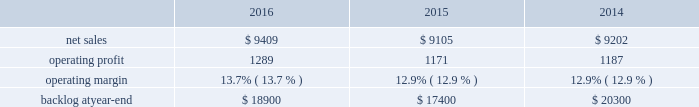Segment includes awe and our share of earnings for our investment in ula , which provides expendable launch services to the u.s .
Government .
Space systems 2019 operating results included the following ( in millions ) : .
2016 compared to 2015 space systems 2019 net sales in 2016 increased $ 304 million , or 3% ( 3 % ) , compared to 2015 .
The increase was attributable to net sales of approximately $ 410 million from awe following the consolidation of this business in the third quarter of 2016 ; and approximately $ 150 million for commercial space transportation programs due to increased launch-related activities ; and approximately $ 70 million of higher net sales for various programs ( primarily fleet ballistic missiles ) due to increased volume .
These increases were partially offset by a decrease in net sales of approximately $ 340 million for government satellite programs due to decreased volume ( primarily sbirs and muos ) and the wind-down or completion of mission solutions programs .
Space systems 2019 operating profit in 2016 increased $ 118 million , or 10% ( 10 % ) , compared to 2015 .
The increase was primarily attributable to a non-cash , pre-tax gain of approximately $ 127 million related to the consolidation of awe ; and approximately $ 80 million of increased equity earnings from joint ventures ( primarily ula ) .
These increases were partially offset by a decrease of approximately $ 105 million for government satellite programs due to lower risk retirements ( primarily sbirs , muos and mission solutions programs ) and decreased volume .
Adjustments not related to volume , including net profit booking rate adjustments , were approximately $ 185 million lower in 2016 compared to 2015 .
2015 compared to 2014 space systems 2019 net sales in 2015 decreased $ 97 million , or 1% ( 1 % ) , compared to 2014 .
The decrease was attributable to approximately $ 335 million lower net sales for government satellite programs due to decreased volume ( primarily aehf ) and the wind-down or completion of mission solutions programs ; and approximately $ 55 million for strategic missile and defense systems due to lower volume .
These decreases were partially offset by higher net sales of approximately $ 235 million for businesses acquired in 2014 ; and approximately $ 75 million for the orion program due to increased volume .
Space systems 2019 operating profit in 2015 decreased $ 16 million , or 1% ( 1 % ) , compared to 2014 .
Operating profit increased approximately $ 85 million for government satellite programs due primarily to increased risk retirements .
This increase was offset by lower operating profit of approximately $ 65 million for commercial satellite programs due to performance matters on certain programs ; and approximately $ 35 million due to decreased equity earnings in joint ventures .
Adjustments not related to volume , including net profit booking rate adjustments and other matters , were approximately $ 105 million higher in 2015 compared to 2014 .
Equity earnings total equity earnings recognized by space systems ( primarily ula ) represented approximately $ 325 million , $ 245 million and $ 280 million , or 25% ( 25 % ) , 21% ( 21 % ) and 24% ( 24 % ) of this business segment 2019s operating profit during 2016 , 2015 and backlog backlog increased in 2016 compared to 2015 primarily due to the addition of awe 2019s backlog .
Backlog decreased in 2015 compared to 2014 primarily due to lower orders for government satellite programs and the orion program and higher sales on the orion program .
Trends we expect space systems 2019 2017 net sales to decrease in the mid-single digit percentage range as compared to 2016 , driven by program lifecycles on government satellite programs , partially offset by the recognition of awe net sales for a full year in 2017 versus a partial year in 2016 following the consolidation of awe in the third quarter of 2016 .
Operating profit .
What is the growth rate of net sales from 2014 to 2015? 
Computations: ((9105 - 9202) / 9202)
Answer: -0.01054. 